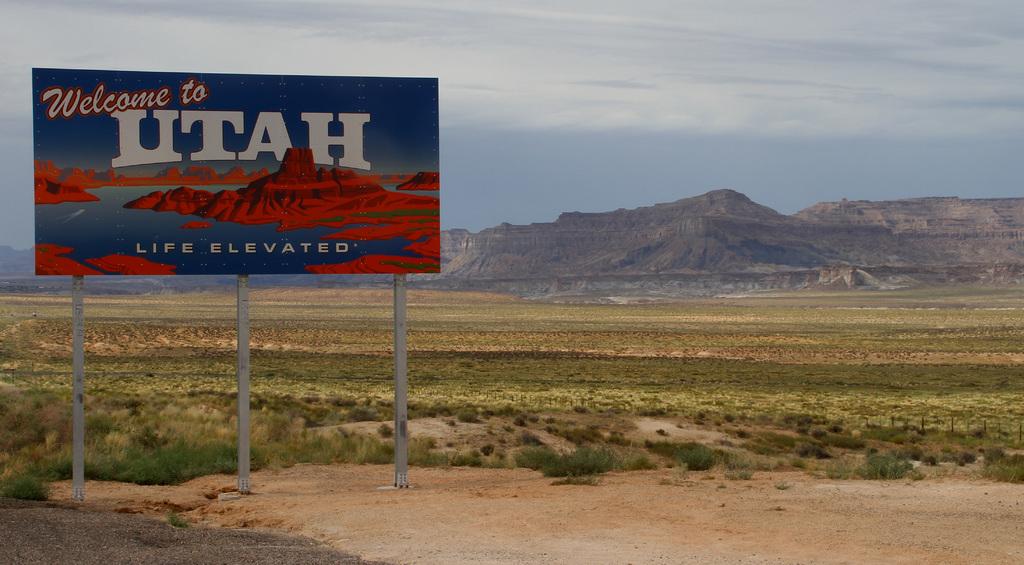What does the sign say?
Your response must be concise. Welcome to utah. What is elevated?
Give a very brief answer. Life. 